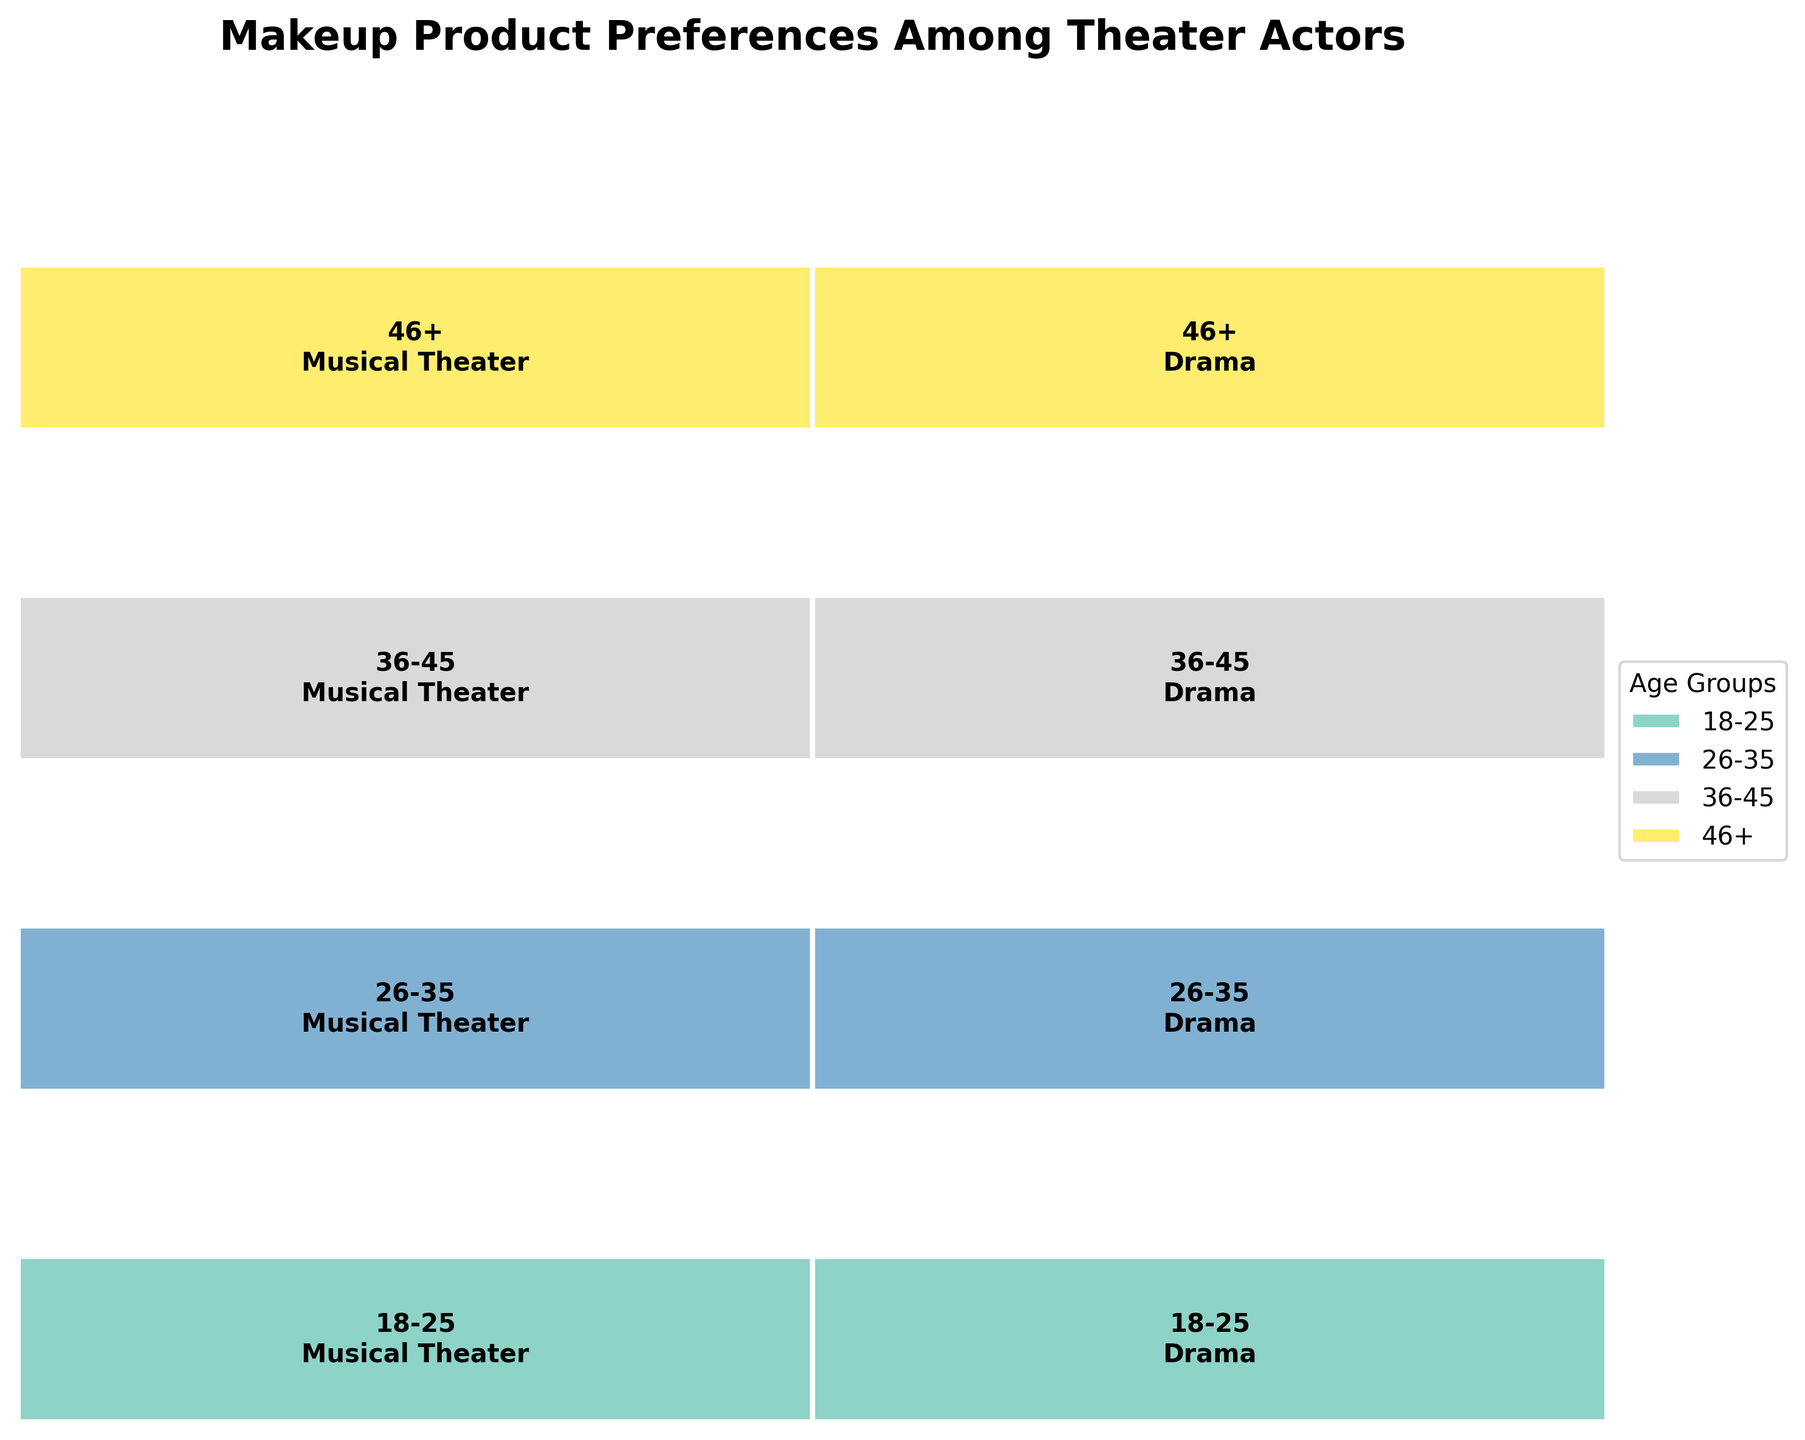Which age group prefers the most diverse range of makeup brands? The plot is divided into sections by age groups and performance genres. By looking at the variation in makeup brands within each age group, we can see that the age group 18-25 has the highest variety of makeup brands across different genres.
Answer: 18-25 What is the most preferred makeup brand for Drama performances by actors aged 26-35? To find this, look at the section of the plot for age group 26-35 under Drama. The most visible brand for this group and genre would be marked within that space.
Answer: Ben Nye How does the preference for MAC Cosmetics vary across different age groups? Check the sections colored differently by age groups and locate MAC Cosmetics. It appears only in the 18-25 age group within Musical Theater.
Answer: Only in 18-25 Which age group has a nearly equal preference for two different makeup brands within Musical Theater? By looking at the shapes and sizes in the sections, the 36-45 age group shows similar sizes for Estée Lauder and Bobbi Brown in Musical Theater.
Answer: 36-45 Among actors aged 46+, which genre shows a marked preference for high-end brands like Chanel and Dior? Observe the portion of the plot for actors aged 46+. In the Musical Theater section, Lancôme and Chanel are prevalent, showing a preference for high-end brands. In Drama, it is Giorgio Armani and Dior.
Answer: Both genres show high-end brand preferences Which age group has the least diversity in makeup brand preferences within Drama Performances? Check the areas for Drama across all age groups. The 36-45 age group has the least brand variation, only showing Laura Mercier and Shiseido.
Answer: 36-45 Do older actors (46+) have a stronger preference for premium makeup brands compared to younger actors (18-25)? Evaluate the brands listed for ages 46+ (Lancôme, Chanel, Giorgio Armani, Dior) against those in the 18-25 bracket (MAC Cosmetics, Urban Decay, Kryolan, Mehron). Premium brands are more prominent in the older group.
Answer: Yes Which performance genre shows a similar or equal preference for more than one makeup brand among the youngest age group (18-25)? Examine the plot sections for the 18-25 age group, both for Musical Theater and Drama. MAC Cosmetics and Urban Decay are nearly equal within Musical Theater.
Answer: Musical Theater Is there any genre where actors aged 26-35 show a preference towards specialty theater makeup brands like Ben Nye and Illamasqua? Focus on the Drama section for the 26-35 age group, where Ben Nye and Illamasqua are listed.
Answer: Drama How does the makeup brand preference in Musical Theater for age groups 26-35 and 36-45 compare? Compare the preferred brands within the Musical Theater sections for the two age groups. 26-35 prefers Make Up For Ever and NARS, while 36-45 prefers Estée Lauder and Bobbi Brown.
Answer: Different brands 